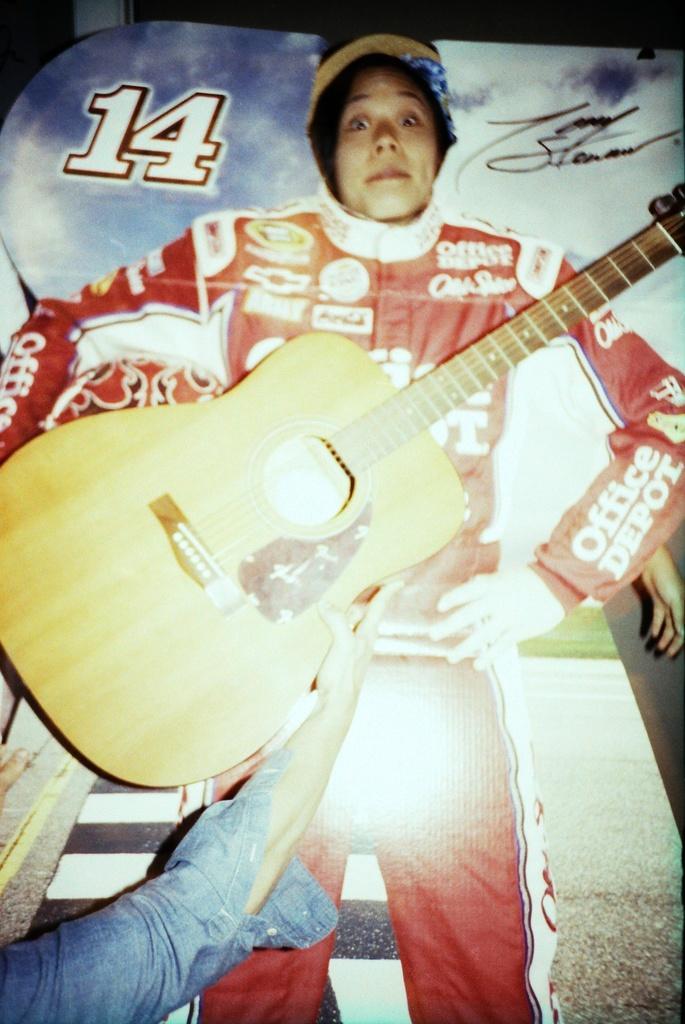Please provide a concise description of this image. In this picture we can see a guitar holding with the hand back side one girl is in standing position and that is it flexi poster 